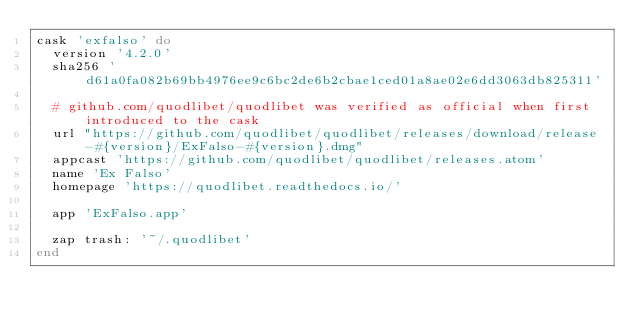<code> <loc_0><loc_0><loc_500><loc_500><_Ruby_>cask 'exfalso' do
  version '4.2.0'
  sha256 'd61a0fa082b69bb4976ee9c6bc2de6b2cbae1ced01a8ae02e6dd3063db825311'

  # github.com/quodlibet/quodlibet was verified as official when first introduced to the cask
  url "https://github.com/quodlibet/quodlibet/releases/download/release-#{version}/ExFalso-#{version}.dmg"
  appcast 'https://github.com/quodlibet/quodlibet/releases.atom'
  name 'Ex Falso'
  homepage 'https://quodlibet.readthedocs.io/'

  app 'ExFalso.app'

  zap trash: '~/.quodlibet'
end
</code> 